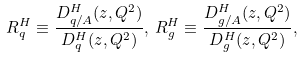<formula> <loc_0><loc_0><loc_500><loc_500>R _ { q } ^ { H } \equiv \frac { D ^ { H } _ { q / A } ( z , Q ^ { 2 } ) } { D ^ { H } _ { q } ( z , Q ^ { 2 } ) } , \, R _ { g } ^ { H } \equiv \frac { D ^ { H } _ { g / A } ( z , Q ^ { 2 } ) } { D ^ { H } _ { g } ( z , Q ^ { 2 } ) } ,</formula> 